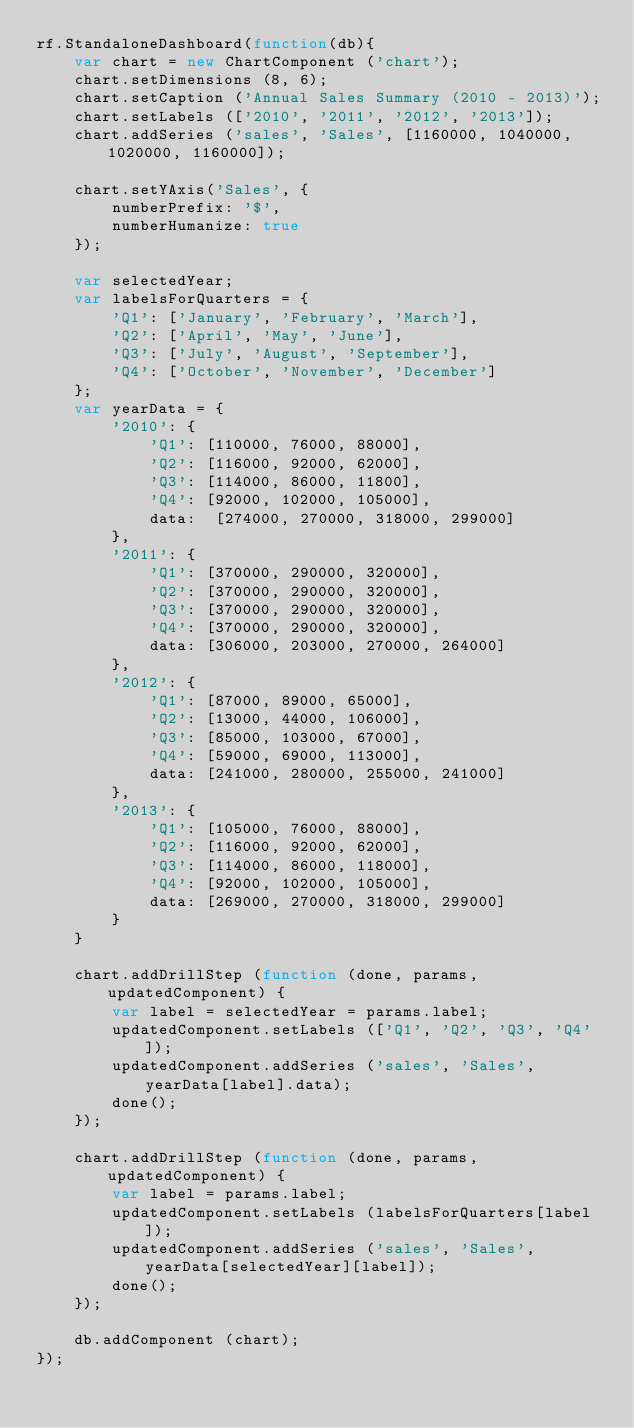<code> <loc_0><loc_0><loc_500><loc_500><_JavaScript_>rf.StandaloneDashboard(function(db){
    var chart = new ChartComponent ('chart');
    chart.setDimensions (8, 6);
    chart.setCaption ('Annual Sales Summary (2010 - 2013)');
    chart.setLabels (['2010', '2011', '2012', '2013']);
    chart.addSeries ('sales', 'Sales', [1160000, 1040000, 1020000, 1160000]);

    chart.setYAxis('Sales', {
        numberPrefix: '$',
        numberHumanize: true
    });

    var selectedYear;
    var labelsForQuarters = {
        'Q1': ['January', 'February', 'March'],
        'Q2': ['April', 'May', 'June'],
        'Q3': ['July', 'August', 'September'],
        'Q4': ['October', 'November', 'December']
    };
    var yearData = {
        '2010': {
            'Q1': [110000, 76000, 88000],
            'Q2': [116000, 92000, 62000],
            'Q3': [114000, 86000, 11800],
            'Q4': [92000, 102000, 105000],
            data:  [274000, 270000, 318000, 299000]
        },
        '2011': {
            'Q1': [370000, 290000, 320000],
            'Q2': [370000, 290000, 320000],
            'Q3': [370000, 290000, 320000],
            'Q4': [370000, 290000, 320000],
            data: [306000, 203000, 270000, 264000]
        },
        '2012': {
            'Q1': [87000, 89000, 65000],
            'Q2': [13000, 44000, 106000],
            'Q3': [85000, 103000, 67000],
            'Q4': [59000, 69000, 113000],
            data: [241000, 280000, 255000, 241000]
        },
        '2013': {
            'Q1': [105000, 76000, 88000],
            'Q2': [116000, 92000, 62000],
            'Q3': [114000, 86000, 118000],
            'Q4': [92000, 102000, 105000],
            data: [269000, 270000, 318000, 299000]
        }
    }

    chart.addDrillStep (function (done, params, updatedComponent) {
        var label = selectedYear = params.label;
        updatedComponent.setLabels (['Q1', 'Q2', 'Q3', 'Q4']);
        updatedComponent.addSeries ('sales', 'Sales', yearData[label].data);
        done();
    });

    chart.addDrillStep (function (done, params, updatedComponent) {
        var label = params.label;
        updatedComponent.setLabels (labelsForQuarters[label]);
        updatedComponent.addSeries ('sales', 'Sales', yearData[selectedYear][label]);
        done();
    });

    db.addComponent (chart);
});
</code> 